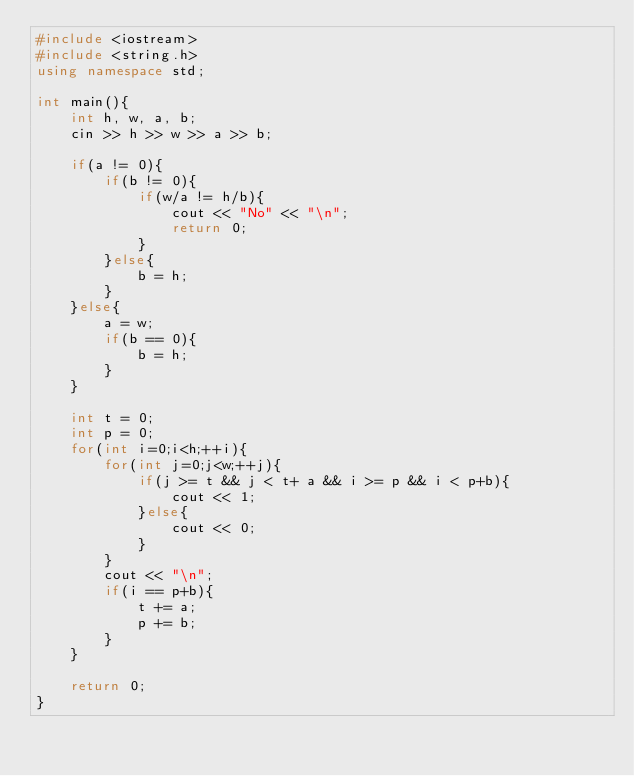<code> <loc_0><loc_0><loc_500><loc_500><_C++_>#include <iostream>
#include <string.h>
using namespace std;

int main(){
    int h, w, a, b;
    cin >> h >> w >> a >> b;

    if(a != 0){
        if(b != 0){
            if(w/a != h/b){
                cout << "No" << "\n";
                return 0;
            }
        }else{
            b = h;
        }
    }else{
        a = w;
        if(b == 0){
            b = h;
        }
    }

    int t = 0;
    int p = 0;
    for(int i=0;i<h;++i){
        for(int j=0;j<w;++j){
            if(j >= t && j < t+ a && i >= p && i < p+b){
                cout << 1;
            }else{
                cout << 0;
            }
        }
        cout << "\n";
        if(i == p+b){
            t += a;
            p += b;
        }
    }

    return 0;
}</code> 